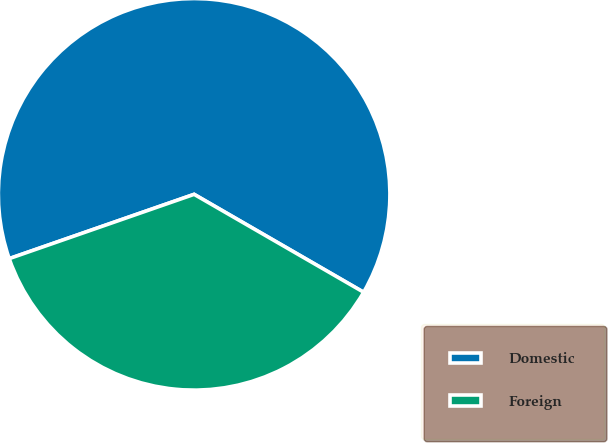Convert chart. <chart><loc_0><loc_0><loc_500><loc_500><pie_chart><fcel>Domestic<fcel>Foreign<nl><fcel>63.66%<fcel>36.34%<nl></chart> 